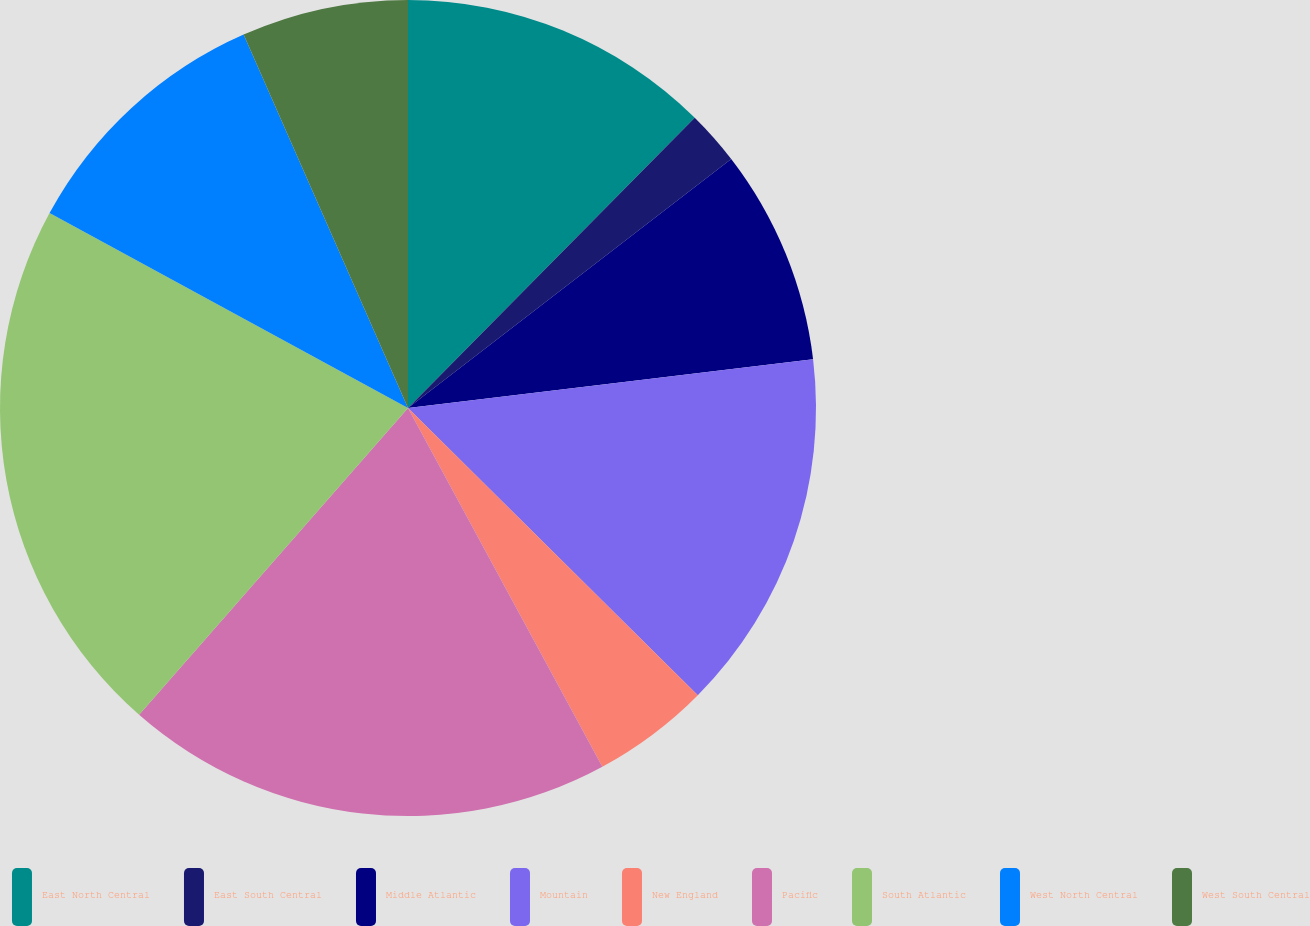<chart> <loc_0><loc_0><loc_500><loc_500><pie_chart><fcel>East North Central<fcel>East South Central<fcel>Middle Atlantic<fcel>Mountain<fcel>New England<fcel>Pacific<fcel>South Atlantic<fcel>West North Central<fcel>West South Central<nl><fcel>12.4%<fcel>2.15%<fcel>8.54%<fcel>14.33%<fcel>4.67%<fcel>19.35%<fcel>21.47%<fcel>10.47%<fcel>6.6%<nl></chart> 